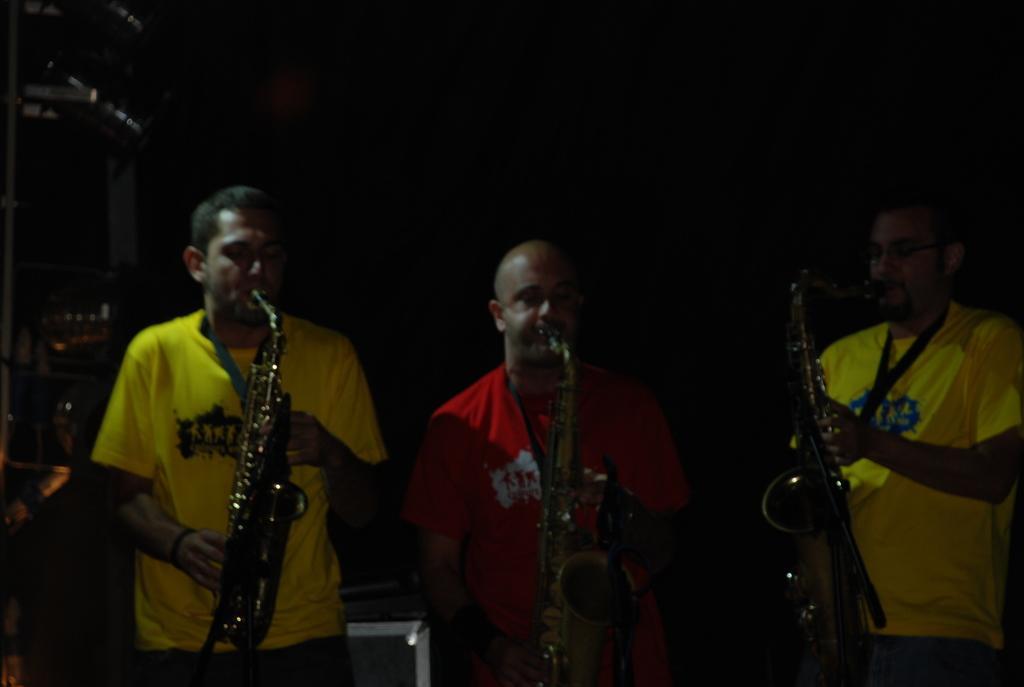Could you give a brief overview of what you see in this image? In this picture there are group of people standing and playing musical instruments. At the back there is an object. On the left side of the image there is an object. 